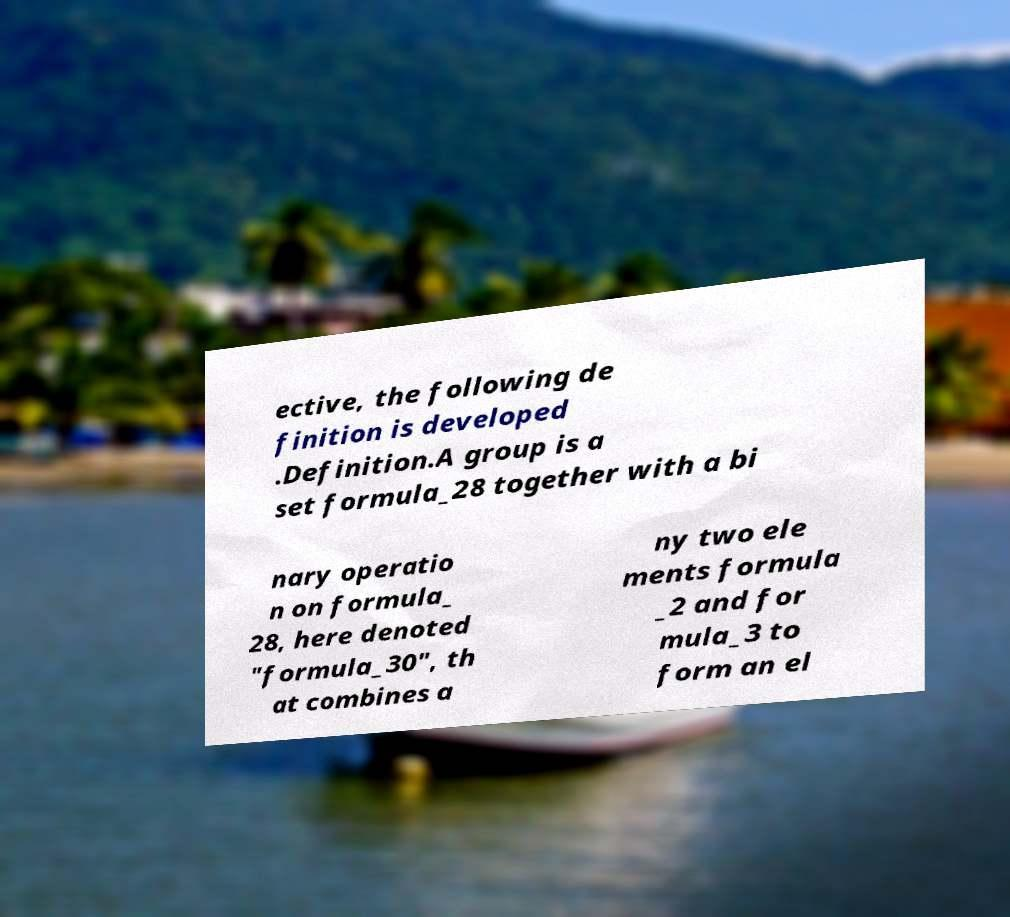Can you read and provide the text displayed in the image?This photo seems to have some interesting text. Can you extract and type it out for me? ective, the following de finition is developed .Definition.A group is a set formula_28 together with a bi nary operatio n on formula_ 28, here denoted "formula_30", th at combines a ny two ele ments formula _2 and for mula_3 to form an el 